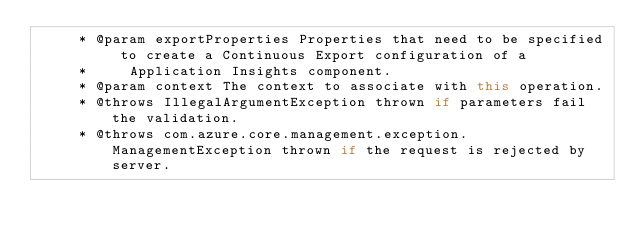<code> <loc_0><loc_0><loc_500><loc_500><_Java_>     * @param exportProperties Properties that need to be specified to create a Continuous Export configuration of a
     *     Application Insights component.
     * @param context The context to associate with this operation.
     * @throws IllegalArgumentException thrown if parameters fail the validation.
     * @throws com.azure.core.management.exception.ManagementException thrown if the request is rejected by server.</code> 